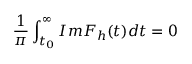Convert formula to latex. <formula><loc_0><loc_0><loc_500><loc_500>\frac { 1 } { \pi } \int _ { t _ { 0 } } ^ { \infty } I m F _ { h } ( t ) d t = 0</formula> 